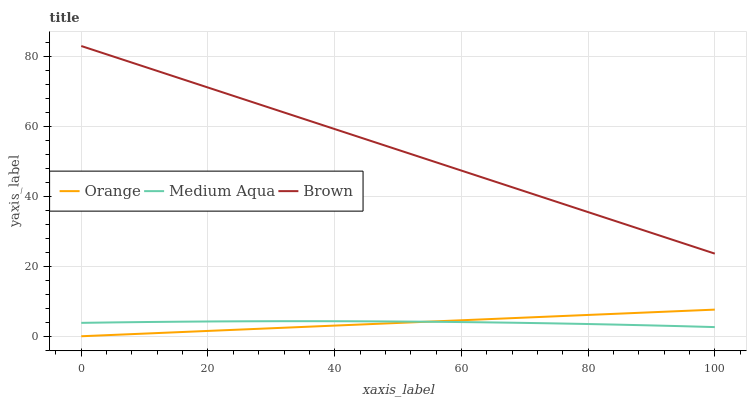Does Orange have the minimum area under the curve?
Answer yes or no. Yes. Does Brown have the maximum area under the curve?
Answer yes or no. Yes. Does Medium Aqua have the minimum area under the curve?
Answer yes or no. No. Does Medium Aqua have the maximum area under the curve?
Answer yes or no. No. Is Orange the smoothest?
Answer yes or no. Yes. Is Medium Aqua the roughest?
Answer yes or no. Yes. Is Brown the smoothest?
Answer yes or no. No. Is Brown the roughest?
Answer yes or no. No. Does Medium Aqua have the lowest value?
Answer yes or no. No. Does Medium Aqua have the highest value?
Answer yes or no. No. Is Orange less than Brown?
Answer yes or no. Yes. Is Brown greater than Orange?
Answer yes or no. Yes. Does Orange intersect Brown?
Answer yes or no. No. 